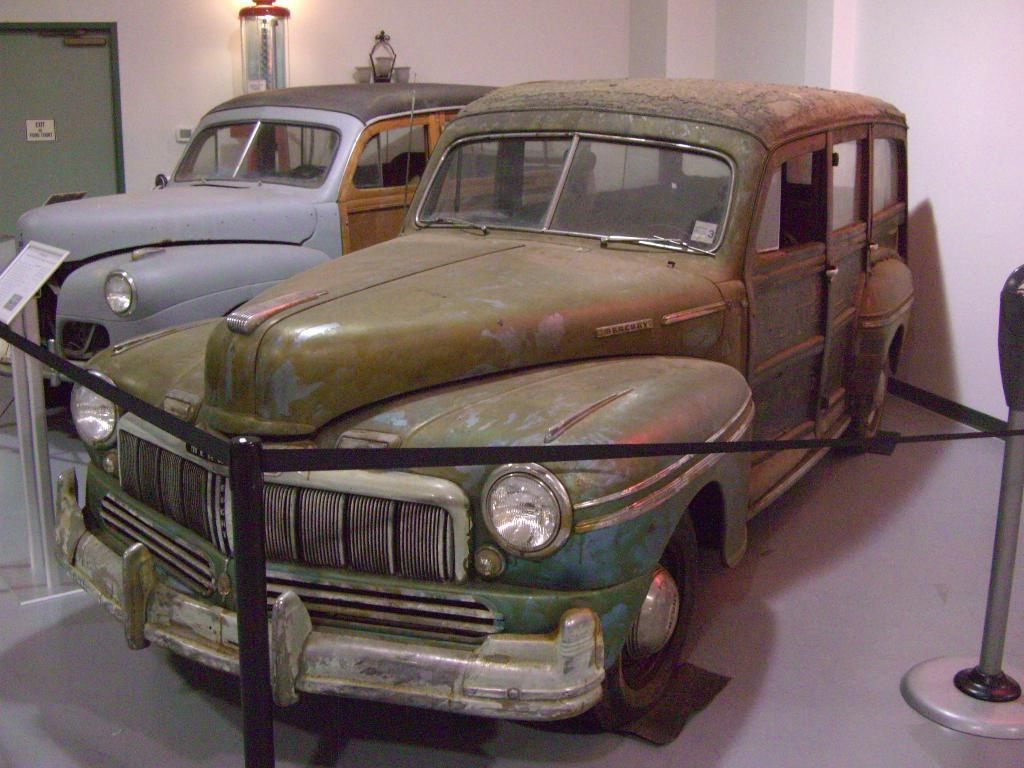How many cars are present in the image? There are two cars in the image. What is in front of the cars? There is a fencing with rods and black color belts in front of the cars. What is visible behind the cars? There is a wall with lamps behind the cars. Can you describe the wall? The wall has a door in it. What is the chance of the queen visiting the location in the image? There is no information about a queen or a visit in the image, so it's not possible to determine the chance of her visiting. 